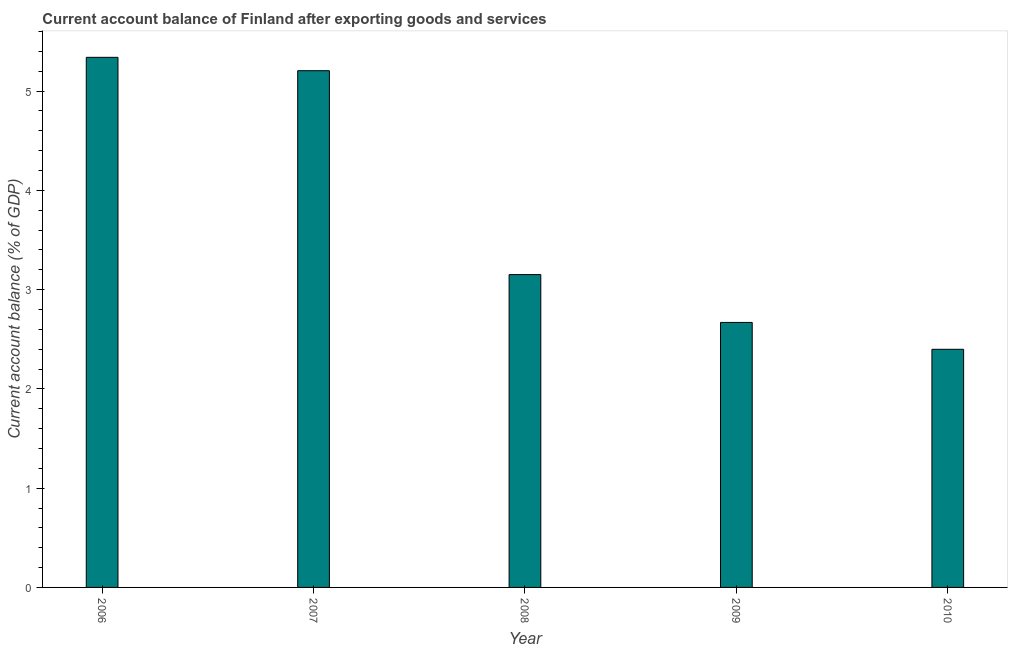Does the graph contain grids?
Your answer should be very brief. No. What is the title of the graph?
Your answer should be very brief. Current account balance of Finland after exporting goods and services. What is the label or title of the Y-axis?
Provide a succinct answer. Current account balance (% of GDP). What is the current account balance in 2007?
Your answer should be very brief. 5.2. Across all years, what is the maximum current account balance?
Keep it short and to the point. 5.34. Across all years, what is the minimum current account balance?
Keep it short and to the point. 2.4. In which year was the current account balance maximum?
Give a very brief answer. 2006. In which year was the current account balance minimum?
Your answer should be very brief. 2010. What is the sum of the current account balance?
Ensure brevity in your answer.  18.76. What is the difference between the current account balance in 2006 and 2007?
Make the answer very short. 0.14. What is the average current account balance per year?
Make the answer very short. 3.75. What is the median current account balance?
Provide a succinct answer. 3.15. In how many years, is the current account balance greater than 1.8 %?
Provide a short and direct response. 5. What is the ratio of the current account balance in 2007 to that in 2009?
Your answer should be compact. 1.95. What is the difference between the highest and the second highest current account balance?
Keep it short and to the point. 0.14. Is the sum of the current account balance in 2007 and 2008 greater than the maximum current account balance across all years?
Provide a succinct answer. Yes. What is the difference between the highest and the lowest current account balance?
Offer a terse response. 2.94. In how many years, is the current account balance greater than the average current account balance taken over all years?
Give a very brief answer. 2. How many bars are there?
Keep it short and to the point. 5. How many years are there in the graph?
Offer a terse response. 5. What is the difference between two consecutive major ticks on the Y-axis?
Give a very brief answer. 1. Are the values on the major ticks of Y-axis written in scientific E-notation?
Offer a very short reply. No. What is the Current account balance (% of GDP) of 2006?
Your answer should be very brief. 5.34. What is the Current account balance (% of GDP) of 2007?
Provide a succinct answer. 5.2. What is the Current account balance (% of GDP) of 2008?
Provide a succinct answer. 3.15. What is the Current account balance (% of GDP) in 2009?
Offer a very short reply. 2.67. What is the Current account balance (% of GDP) in 2010?
Make the answer very short. 2.4. What is the difference between the Current account balance (% of GDP) in 2006 and 2007?
Ensure brevity in your answer.  0.13. What is the difference between the Current account balance (% of GDP) in 2006 and 2008?
Give a very brief answer. 2.19. What is the difference between the Current account balance (% of GDP) in 2006 and 2009?
Ensure brevity in your answer.  2.67. What is the difference between the Current account balance (% of GDP) in 2006 and 2010?
Your response must be concise. 2.94. What is the difference between the Current account balance (% of GDP) in 2007 and 2008?
Ensure brevity in your answer.  2.05. What is the difference between the Current account balance (% of GDP) in 2007 and 2009?
Your answer should be compact. 2.54. What is the difference between the Current account balance (% of GDP) in 2007 and 2010?
Your response must be concise. 2.81. What is the difference between the Current account balance (% of GDP) in 2008 and 2009?
Ensure brevity in your answer.  0.48. What is the difference between the Current account balance (% of GDP) in 2008 and 2010?
Make the answer very short. 0.75. What is the difference between the Current account balance (% of GDP) in 2009 and 2010?
Keep it short and to the point. 0.27. What is the ratio of the Current account balance (% of GDP) in 2006 to that in 2007?
Offer a very short reply. 1.03. What is the ratio of the Current account balance (% of GDP) in 2006 to that in 2008?
Give a very brief answer. 1.7. What is the ratio of the Current account balance (% of GDP) in 2006 to that in 2009?
Make the answer very short. 2. What is the ratio of the Current account balance (% of GDP) in 2006 to that in 2010?
Your answer should be very brief. 2.23. What is the ratio of the Current account balance (% of GDP) in 2007 to that in 2008?
Give a very brief answer. 1.65. What is the ratio of the Current account balance (% of GDP) in 2007 to that in 2009?
Your answer should be compact. 1.95. What is the ratio of the Current account balance (% of GDP) in 2007 to that in 2010?
Your answer should be very brief. 2.17. What is the ratio of the Current account balance (% of GDP) in 2008 to that in 2009?
Provide a short and direct response. 1.18. What is the ratio of the Current account balance (% of GDP) in 2008 to that in 2010?
Provide a succinct answer. 1.31. What is the ratio of the Current account balance (% of GDP) in 2009 to that in 2010?
Your answer should be very brief. 1.11. 